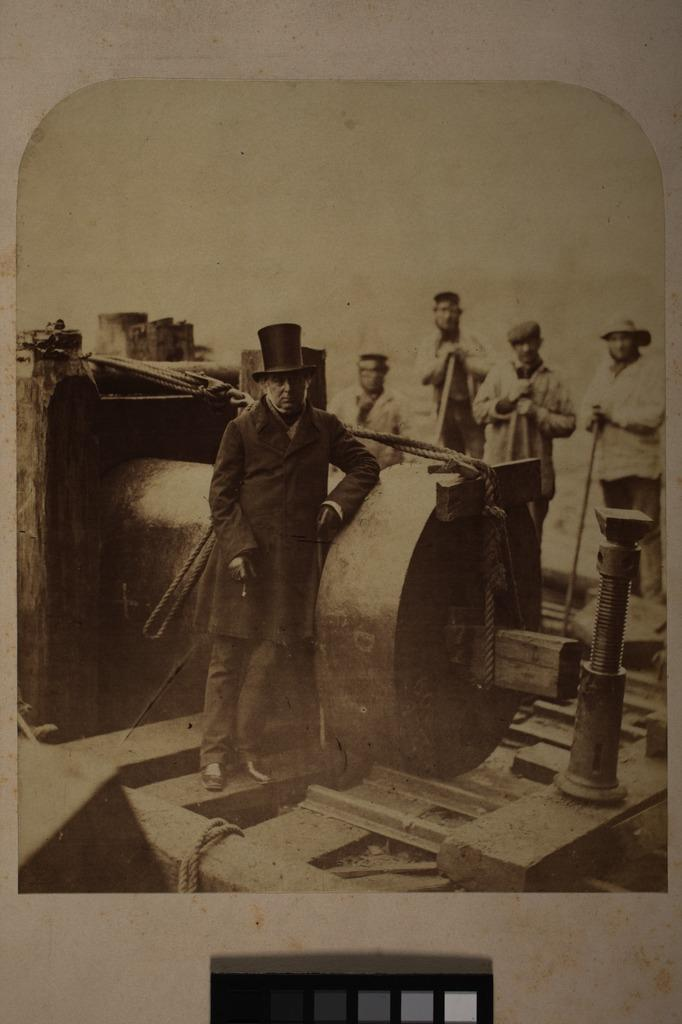How many people are in the image? There are persons standing in the image. What is the main object in the center of the image? There is a machine in the center of the image. Can you identify any other objects in the image? Yes, there is a nut in the image. What type of story is being told by the toothbrush in the image? There is no toothbrush present in the image, so no story can be told by it. 